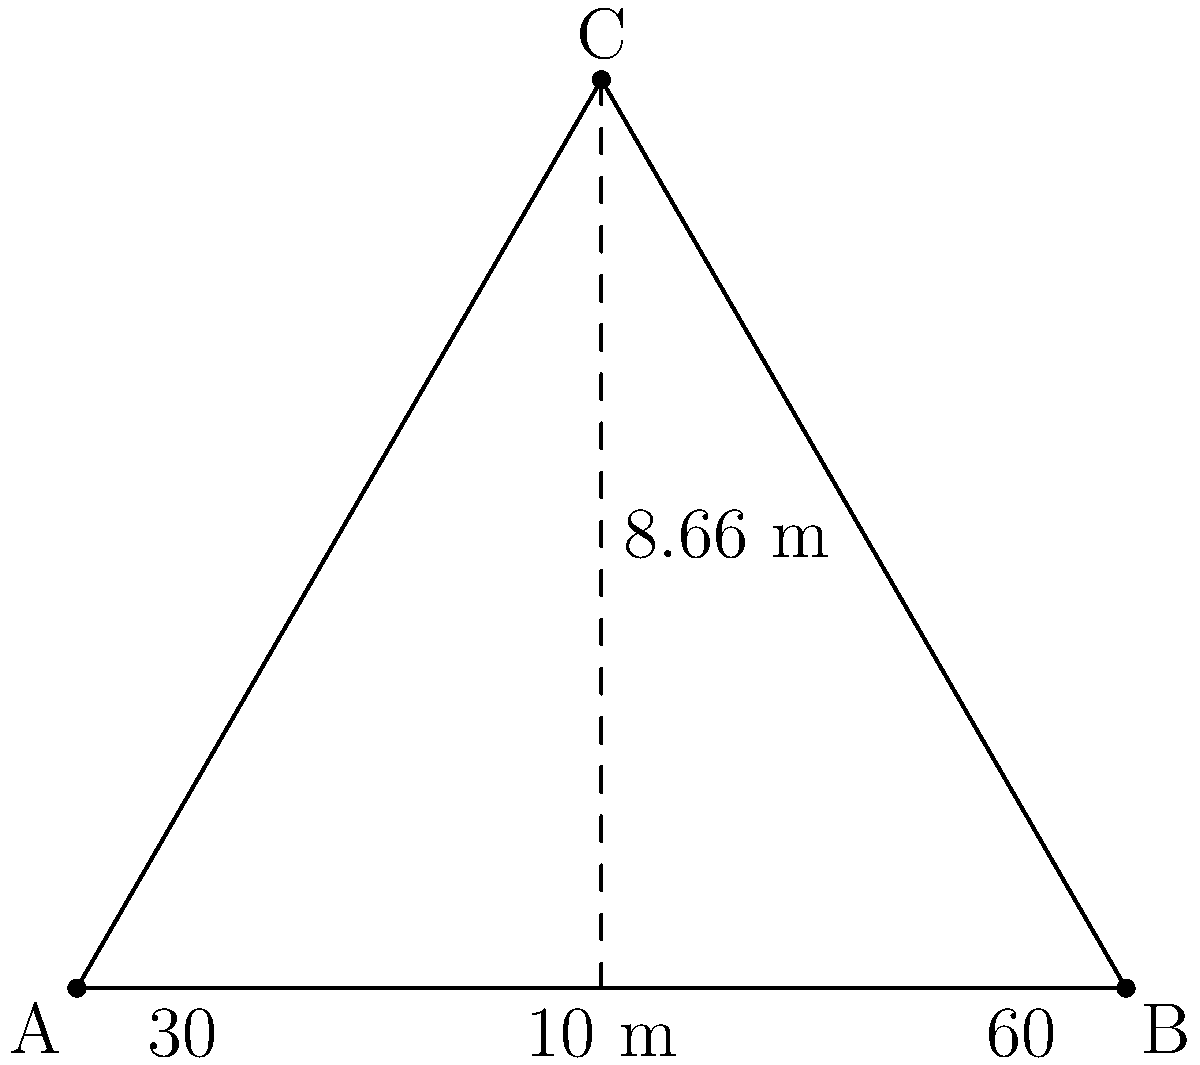In a triangular defensive formation, three defenders are positioned at points A, B, and C. The distance between defenders A and B is 10 meters, and the height of the triangle (perpendicular distance from C to AB) is 8.66 meters. If the angles at the base of the triangle are 30° and 60°, calculate the length of the side AC to determine the coverage area of defender A. Round your answer to two decimal places. Let's approach this step-by-step:

1) We have a right-angled triangle formed by the height of the main triangle and half of its base.

2) In this right-angled triangle:
   - The hypotenuse is the side AC we're looking for.
   - The base is half of AB, which is 5 meters.
   - The height is 8.66 meters.

3) We can use the Pythagorean theorem to find AC:

   $AC^2 = 5^2 + 8.66^2$

4) Let's calculate:
   $AC^2 = 25 + 75.0356 = 100.0356$

5) Taking the square root of both sides:
   $AC = \sqrt{100.0356} \approx 10.0018$ meters

6) Rounding to two decimal places:
   $AC \approx 10.00$ meters

Therefore, the length of side AC, which represents the coverage area of defender A, is approximately 10.00 meters.
Answer: 10.00 meters 